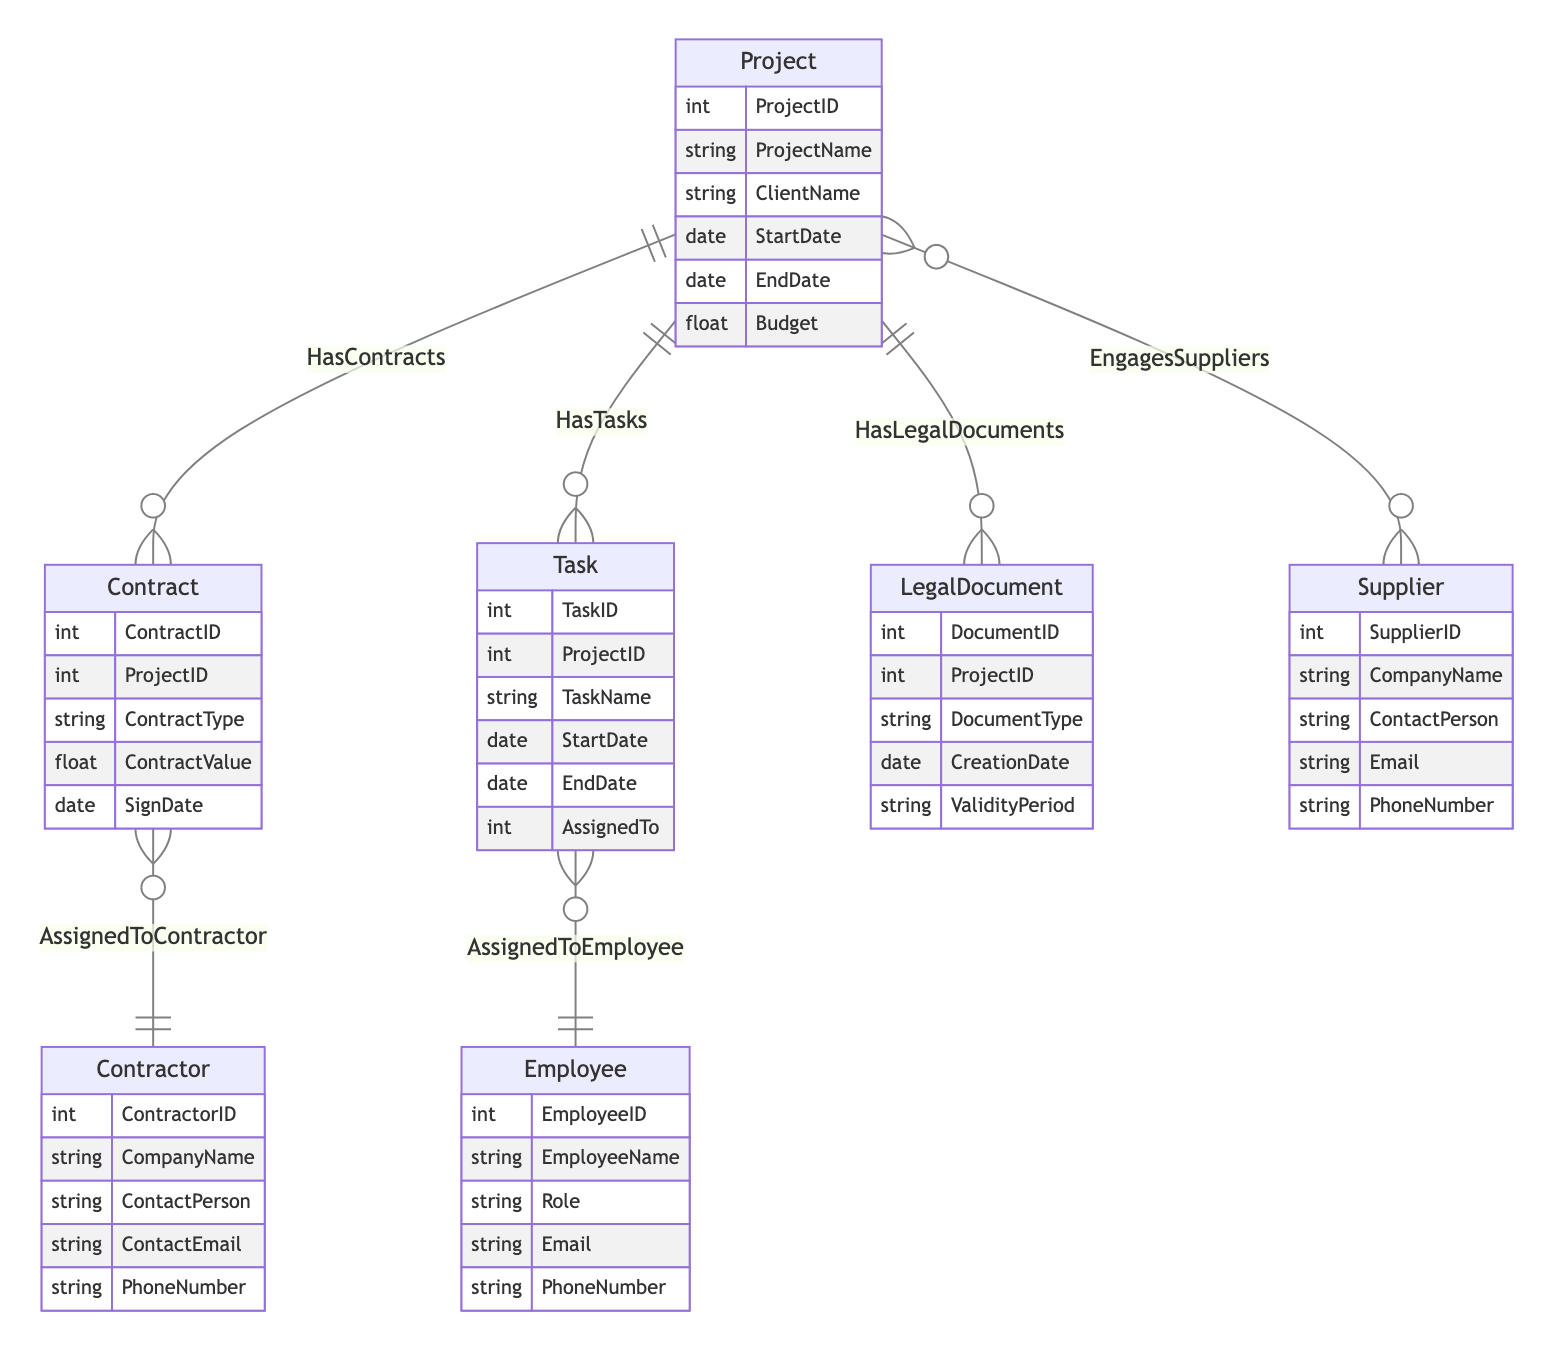What is the relationship type between Project and Contract? The diagram indicates that the relationship between Project and Contract is "1:M," meaning one project can have multiple contracts associated with it.
Answer: 1:M How many attributes does the Contractor entity have? The Contractor entity is shown to have five attributes listed: ContractorID, CompanyName, ContactPerson, ContactEmail, and PhoneNumber. Therefore, the total is five attributes.
Answer: 5 What relationship exists between Task and Employee? The diagram shows a "M:1" relationship between Task and Employee, indicating that multiple tasks can be assigned to a single employee.
Answer: M:1 Which entity has the most relationships connecting to it? The Project entity displays relationships connecting to three different entities: Contract, Task, and LegalDocument, indicating it has the most relationships in the diagram.
Answer: Project How many entities are involved in the EngagesSuppliers relationship? The EngagesSuppliers relationship involves two entities: Project and Supplier, which implies engagement between these two entities.
Answer: 2 What is the cardinality of the relationship between Project and LegalDocument? The relationship between Project and LegalDocument is indicated as "1:M," meaning a single project can have multiple legal documents associated with it.
Answer: 1:M What is the primary key attribute of the Task entity? The Task entity's primary key is represented by the attribute named TaskID, which serves as the unique identifier for each task.
Answer: TaskID How many relationships does the Contract entity have? The diagram indicates that the Contract entity has one relationship with Contractor, making it a total of one relationship directly associated with this entity.
Answer: 1 How many unique entities are represented in the diagram? There are a total of seven unique entities shown in the diagram: Project, Contract, Contractor, Task, Employee, LegalDocument, and Supplier. Thus, the number of unique entities is seven.
Answer: 7 